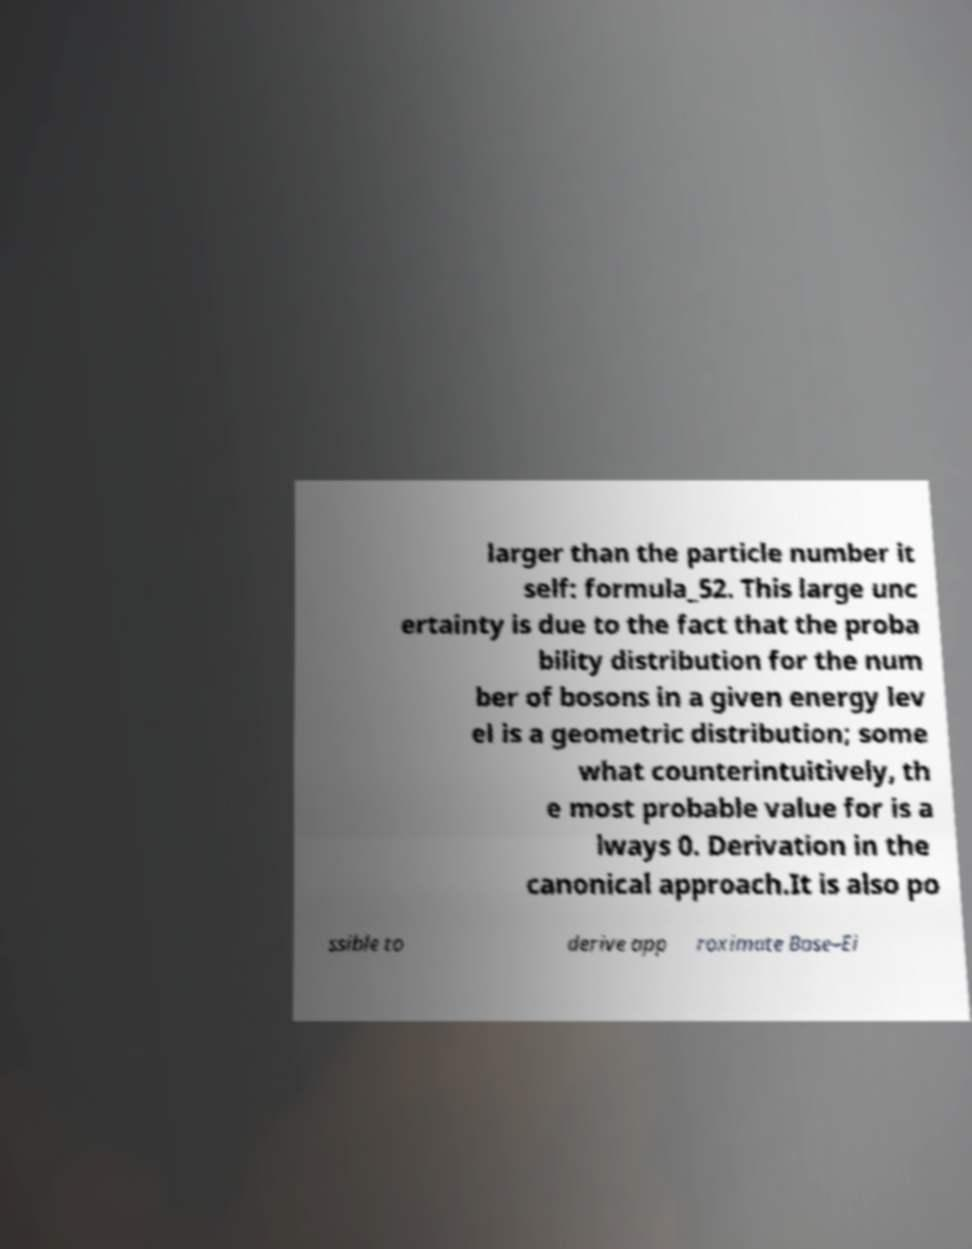Can you accurately transcribe the text from the provided image for me? larger than the particle number it self: formula_52. This large unc ertainty is due to the fact that the proba bility distribution for the num ber of bosons in a given energy lev el is a geometric distribution; some what counterintuitively, th e most probable value for is a lways 0. Derivation in the canonical approach.It is also po ssible to derive app roximate Bose–Ei 